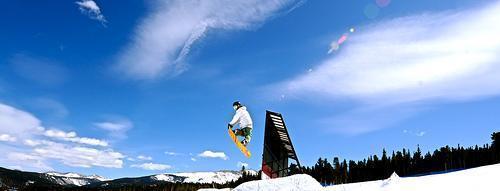How many snowboarders are in this picture?
Give a very brief answer. 1. How many ramps are in this image?
Give a very brief answer. 1. How many kangaroos are in this photograph?
Give a very brief answer. 0. 